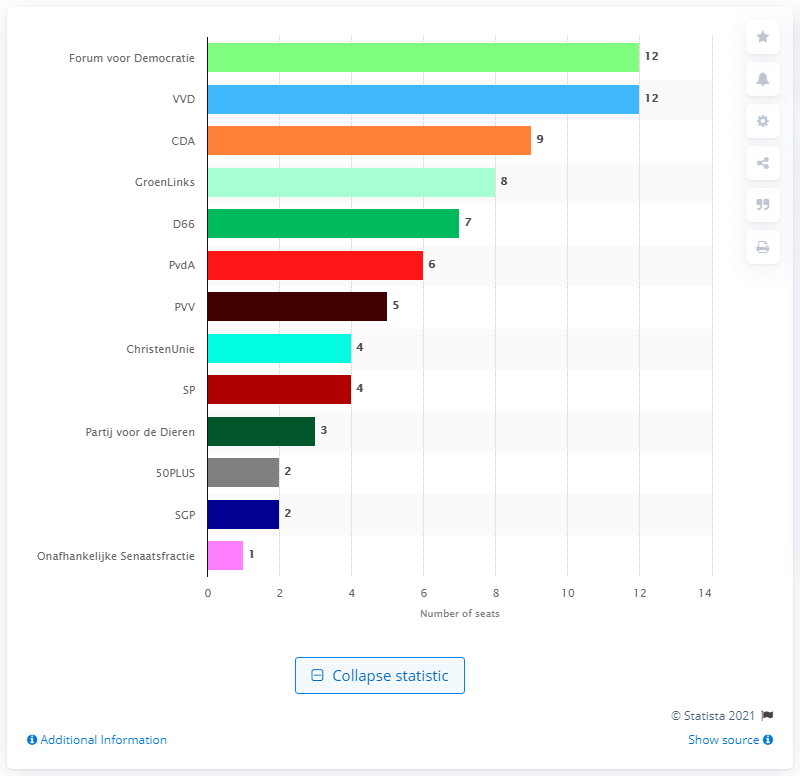Mention a couple of crucial points in this snapshot. The Forum voor Democratie won 12 seats in the 2019 elections. The name of the People's Party for Freedom and Democracy is the VVD. 